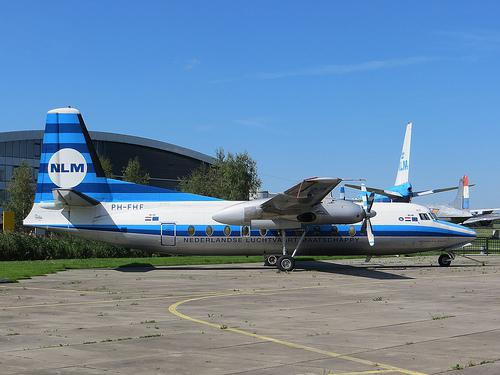Question: what color is the sky?
Choices:
A. White.
B. Gray.
C. Blue.
D. Orange.
Answer with the letter. Answer: C 